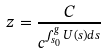Convert formula to latex. <formula><loc_0><loc_0><loc_500><loc_500>z = \frac { C } { c ^ { \int _ { s _ { 0 } } ^ { g } U ( s ) d s } }</formula> 